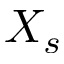Convert formula to latex. <formula><loc_0><loc_0><loc_500><loc_500>X _ { s }</formula> 